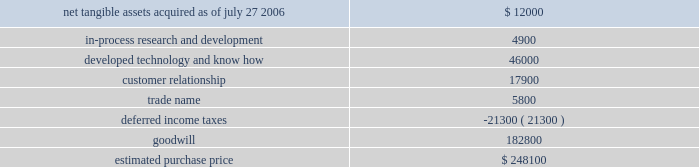Hologic , inc .
Notes to consolidated financial statements ( continued ) ( in thousands , except per share data ) the aggregate purchase price for suros of approximately $ 248000 ( subject to adjustment ) consisted of 2300 shares of hologic common stock valued at $ 106500 , cash paid of $ 139000 , and approximately $ 2600 for acquisition related fees and expenses .
The company determined the fair value of the shares issued in connection with the acquisition in accordance with eitf issue no .
99-12 , determination of the measurement date for the market price of acquirer securities issued in a purchase business combination .
The components and allocation of the purchase price , consists of the following approximate amounts: .
The acquisition also provides for a two-year earn out .
The earn-out will be payable in two annual cash installments equal to the incremental revenue growth in suros 2019 business in the two years following the closing .
The company has considered the provision of eitf issue no .
95-8 , accounting for contingent consideration paid to the shareholders of and acquired enterprise in a purchase business combination , and concluded that this contingent consideration represents additional purchase price .
As a result , goodwill will be increased by the amount of the additional consideration , if any , when it becomes due and payable .
As part of the purchase price allocation , all intangible assets that were a part of the acquisition were identified and valued .
It was determined that only customer lists , trademarks and developed technology had separately identifiable values .
Customer relationships represents suros large installed base that are expected to purchase disposable products on a regular basis .
Trademarks represent the suros product names that the company intends to continue to use .
Developed technology represents currently marketable purchased products that the company continues to resell as well as utilize to enhance and incorporate into the company 2019s existing products .
The estimated $ 4900 of purchase price allocated to in-process research and development projects primarily related to suros 2019 disposable products .
The projects are of various stages of completion and include next generation handpiece and site marker technologies .
The company expects that these projects will be completed during fiscal 2007 .
The deferred income tax liability relates to the tax effect of acquired identifiable intangible assets , and fair value adjustments to acquired inventory as such amounts are not deductible for tax purposes , partially offset by acquired net operating loss carry forwards that the company believes are realizable .
For all of the acquisitions discussed above , goodwill represents the excess of the purchase price over the net identifiable tangible and intangible assets acquired .
The company determined that the acquisition of each aeg , r2 and suros resulted in the recognition of goodwill primarily because of synergies unique to the company and the strength of its acquired workforce .
Supplemental pro-forma information the following unaudited pro forma information presents the consolidated results of operations of the company , r2 and suros as if the acquisitions had occurred at the beginning of each of fiscal 2006 and 2005 .
What percentage of the estimated purchase price is due to goodwill? 
Computations: (182800 / 248100)
Answer: 0.7368. 